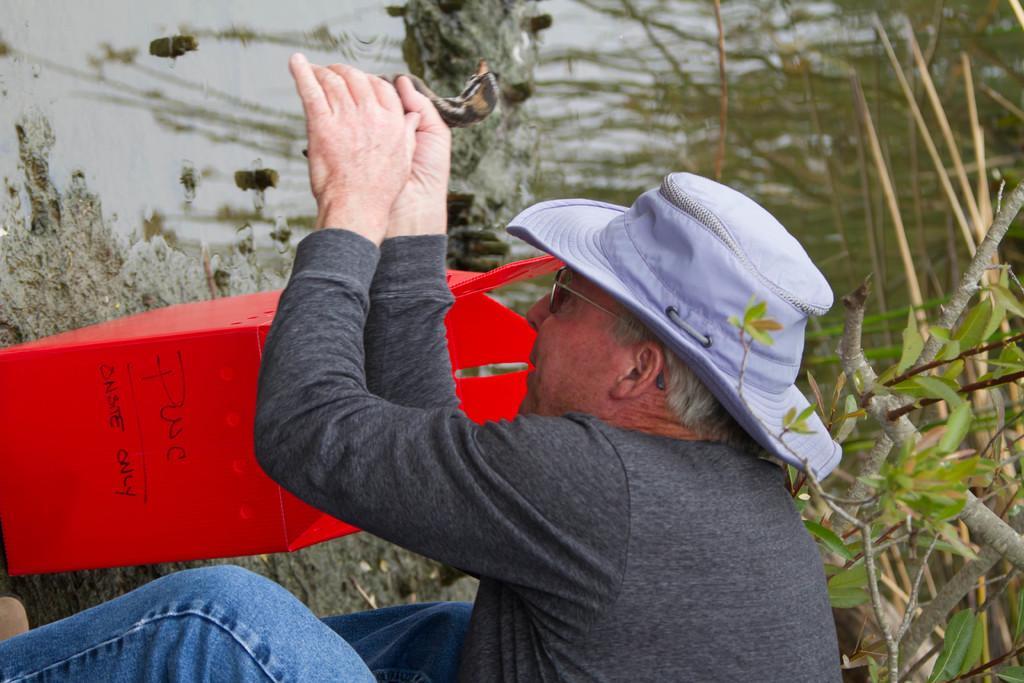How would you summarize this image in a sentence or two? In this image in the foreground there is one person who is holding some bird, and in the background there is a red color object and some plants and grass and there is a sea. 